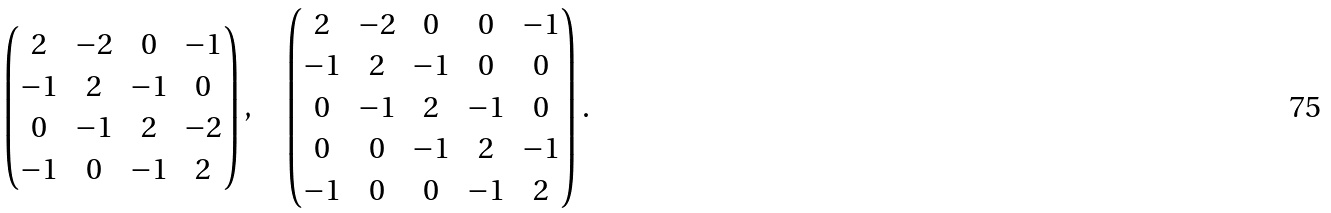Convert formula to latex. <formula><loc_0><loc_0><loc_500><loc_500>\begin{pmatrix} 2 & - 2 & 0 & - 1 \\ - 1 & 2 & - 1 & 0 \\ 0 & - 1 & 2 & - 2 \\ - 1 & 0 & - 1 & 2 \end{pmatrix} , \quad \begin{pmatrix} 2 & - 2 & 0 & 0 & - 1 \\ - 1 & 2 & - 1 & 0 & 0 \\ 0 & - 1 & 2 & - 1 & 0 \\ 0 & 0 & - 1 & 2 & - 1 \\ - 1 & 0 & 0 & - 1 & 2 \end{pmatrix} .</formula> 